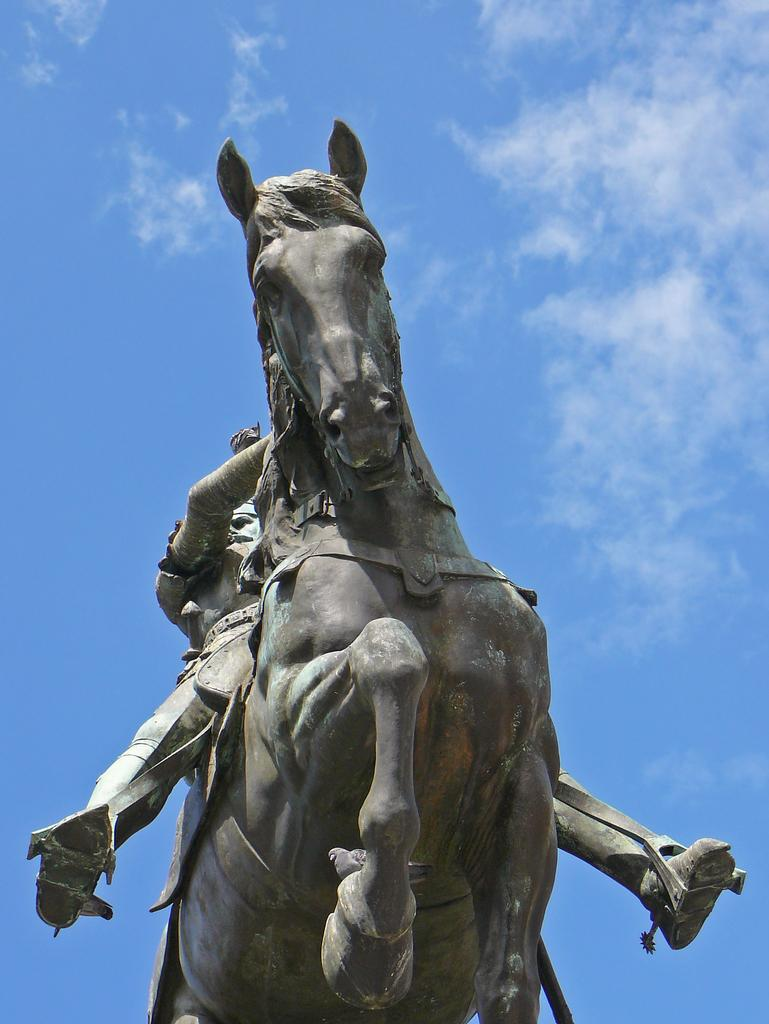What is depicted in the sculpture in the image? The sculpture in the image is of a person and a horse. What can be seen in the background of the image? The sky is visible in the background of the image. How would you describe the sky in the image? The sky appears to be clear in the image. What type of account does the person in the sculpture have with the bank in the image? There is no bank or account mentioned in the image; it features a sculpture of a person and a horse with a clear sky in the background. 